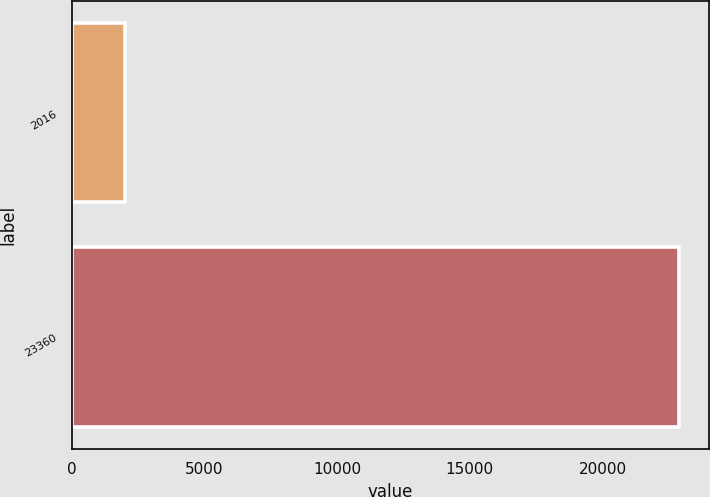Convert chart to OTSL. <chart><loc_0><loc_0><loc_500><loc_500><bar_chart><fcel>2016<fcel>23360<nl><fcel>2015<fcel>22878<nl></chart> 